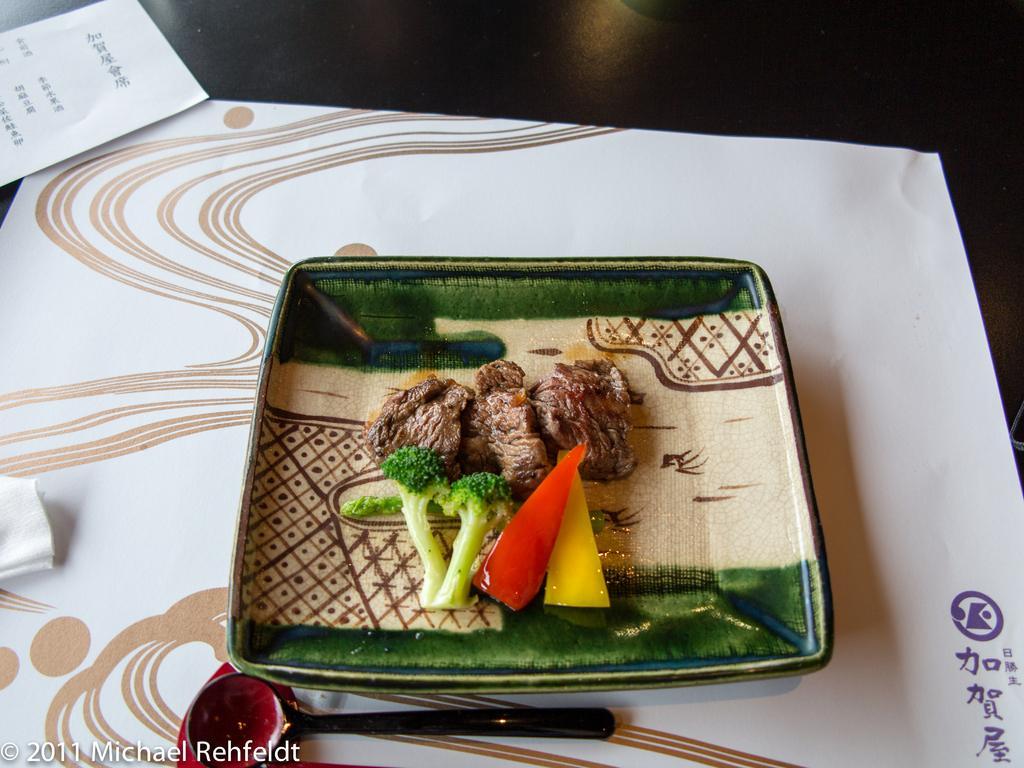Please provide a concise description of this image. In this image I can see a plate on a table and some food on the plate. I can see a spoon, a paper napkin and a paper with some text on the table.  